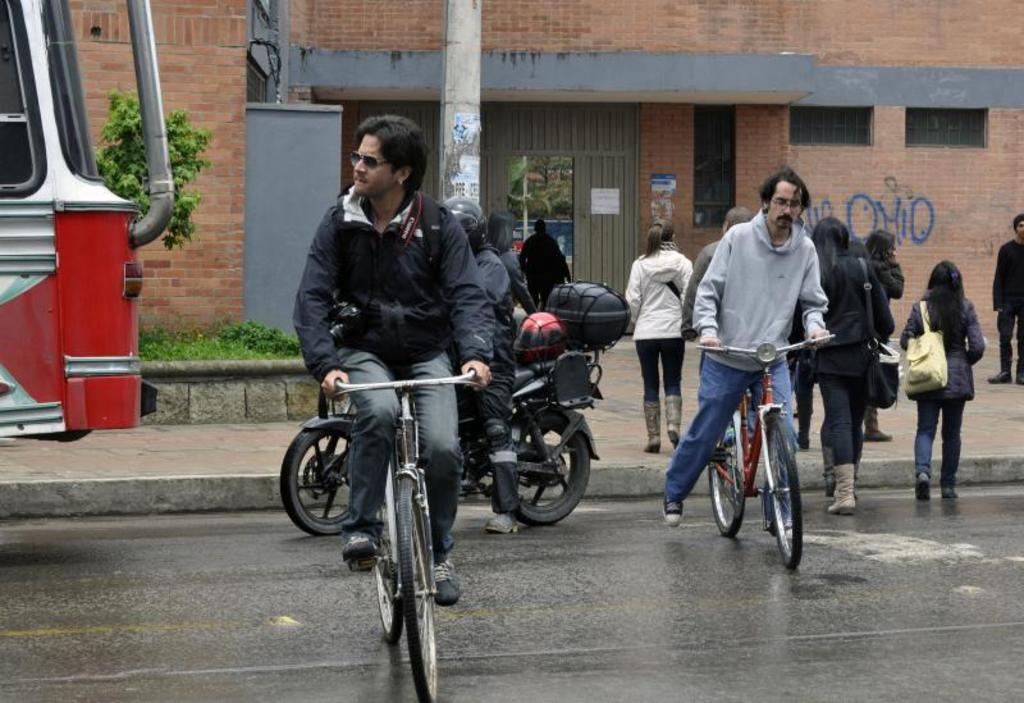How many people are present in the image? There are many persons in the image. What type of structure can be seen in the image? There is a building in the image. What natural elements are present in the image? There is a tree and grass in the image. What mode of transportation is visible in the image? There is a vehicle in the image. What activity are two persons engaged in within the image? Two persons are driving a bicycle in the image. What type of flesh can be seen hanging from the tree in the image? There is no flesh hanging from the tree in the image; it is a tree with leaves or branches. Where is the middle of the image located? The concept of a "middle" of the image is not applicable, as the image is a two-dimensional representation. What type of cord is connected to the vehicle in the image? There is no cord connected to the vehicle in the image. 